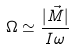<formula> <loc_0><loc_0><loc_500><loc_500>\Omega \simeq \frac { | \vec { M } | } { I \omega }</formula> 